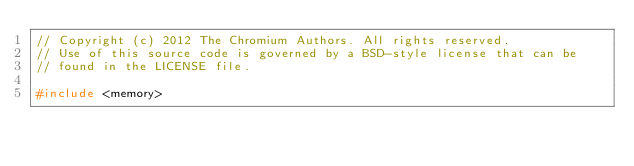<code> <loc_0><loc_0><loc_500><loc_500><_C++_>// Copyright (c) 2012 The Chromium Authors. All rights reserved.
// Use of this source code is governed by a BSD-style license that can be
// found in the LICENSE file.

#include <memory>
</code> 